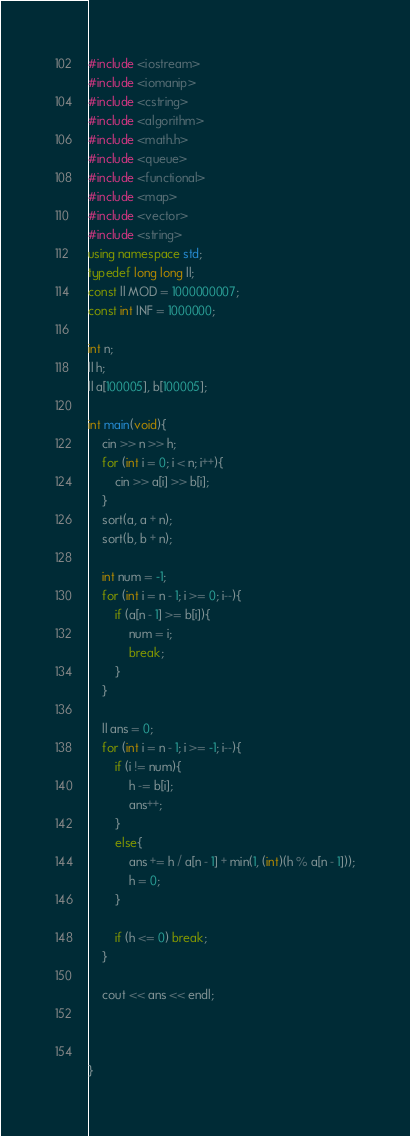Convert code to text. <code><loc_0><loc_0><loc_500><loc_500><_C++_>#include <iostream>
#include <iomanip>
#include <cstring>
#include <algorithm> 
#include <math.h>
#include <queue>
#include <functional>
#include <map>
#include <vector>
#include <string>
using namespace std;
typedef long long ll;
const ll MOD = 1000000007;
const int INF = 1000000;

int n;
ll h;
ll a[100005], b[100005];

int main(void){
    cin >> n >> h;
    for (int i = 0; i < n; i++){
        cin >> a[i] >> b[i];
    }
    sort(a, a + n);
    sort(b, b + n);

    int num = -1;
    for (int i = n - 1; i >= 0; i--){
        if (a[n - 1] >= b[i]){
            num = i;
            break;
        }
    }

    ll ans = 0;
    for (int i = n - 1; i >= -1; i--){
        if (i != num){
            h -= b[i];
            ans++;
        }
        else{
            ans += h / a[n - 1] + min(1, (int)(h % a[n - 1]));
            h = 0;
        }

        if (h <= 0) break;
    }

    cout << ans << endl;
    
    

}</code> 